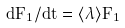<formula> <loc_0><loc_0><loc_500><loc_500>d F _ { 1 } / d t = \langle \lambda \rangle F _ { 1 }</formula> 